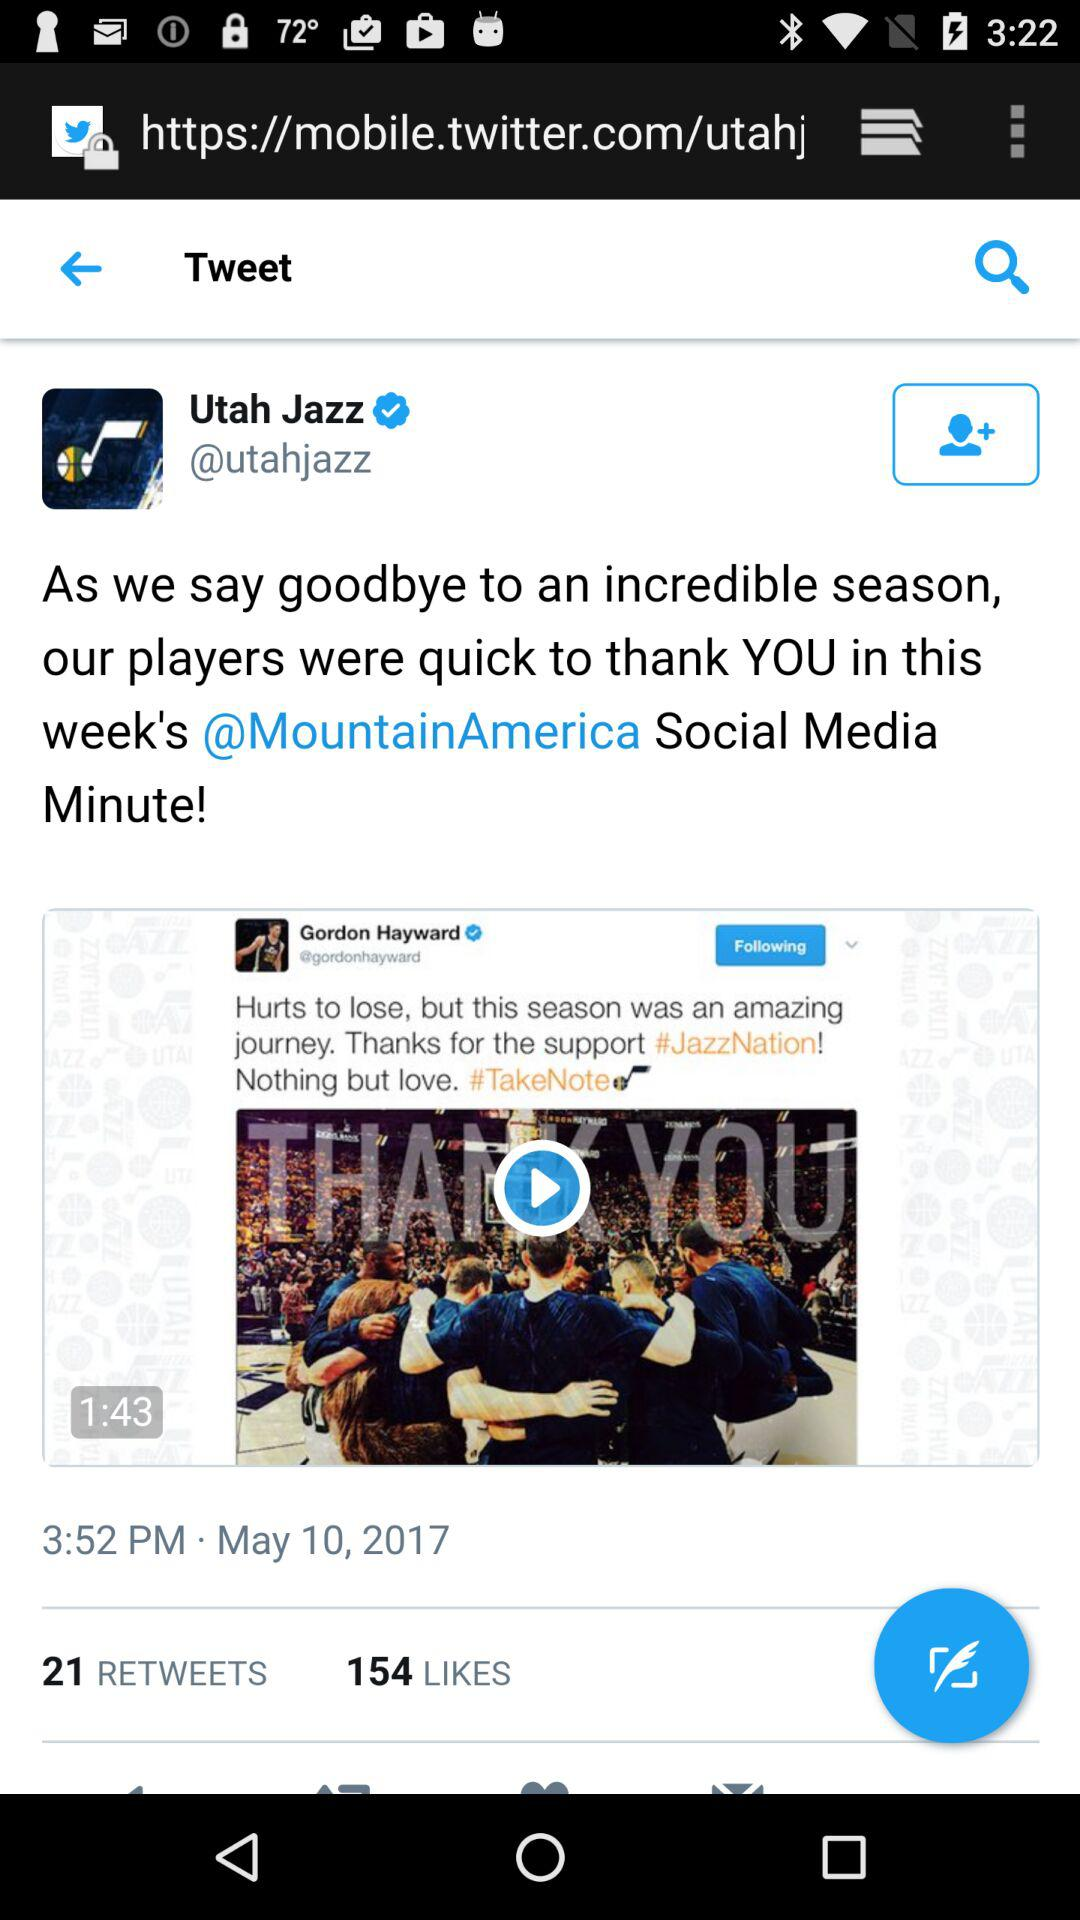On what date did the Utah Jazz update the tweet? The Utah Jazz updated the tweet on May 10, 2017. 